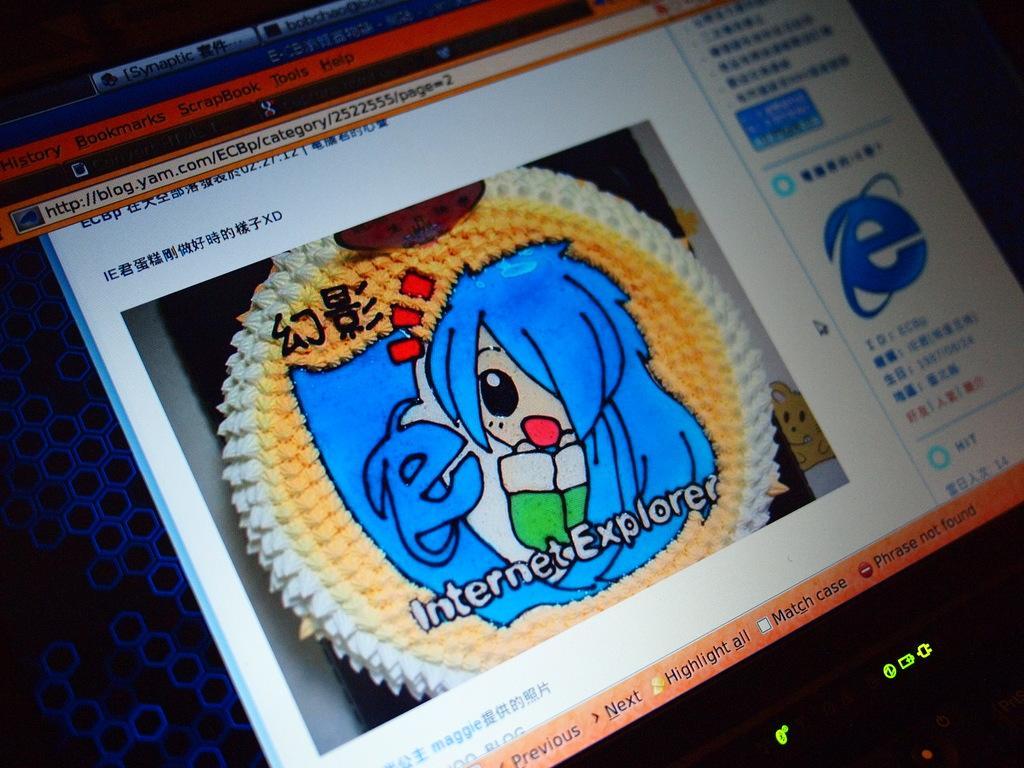In one or two sentences, can you explain what this image depicts? This image consists of a laptop screen. 